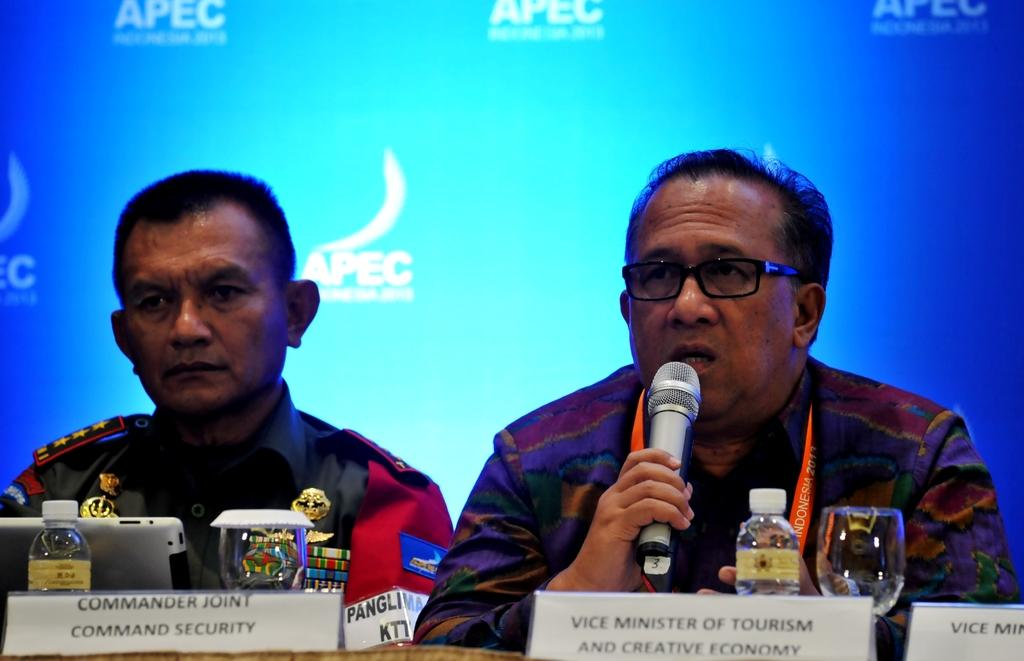How many people are sitting on the chair in the image? There are two persons sitting on a chair in the image. What is one person doing while sitting on the chair? One person is holding a mic. Can you describe the appearance of the person holding the mic? The person holding the mic is wearing spectacles. What objects can be seen on the table in the image? There is a bottle, a glass, and a laptop on the table. What type of apparel is the person wearing on their nose in the image? There is no person wearing apparel on their nose in the image. Where is the library located in the image? There is no library present in the image. 